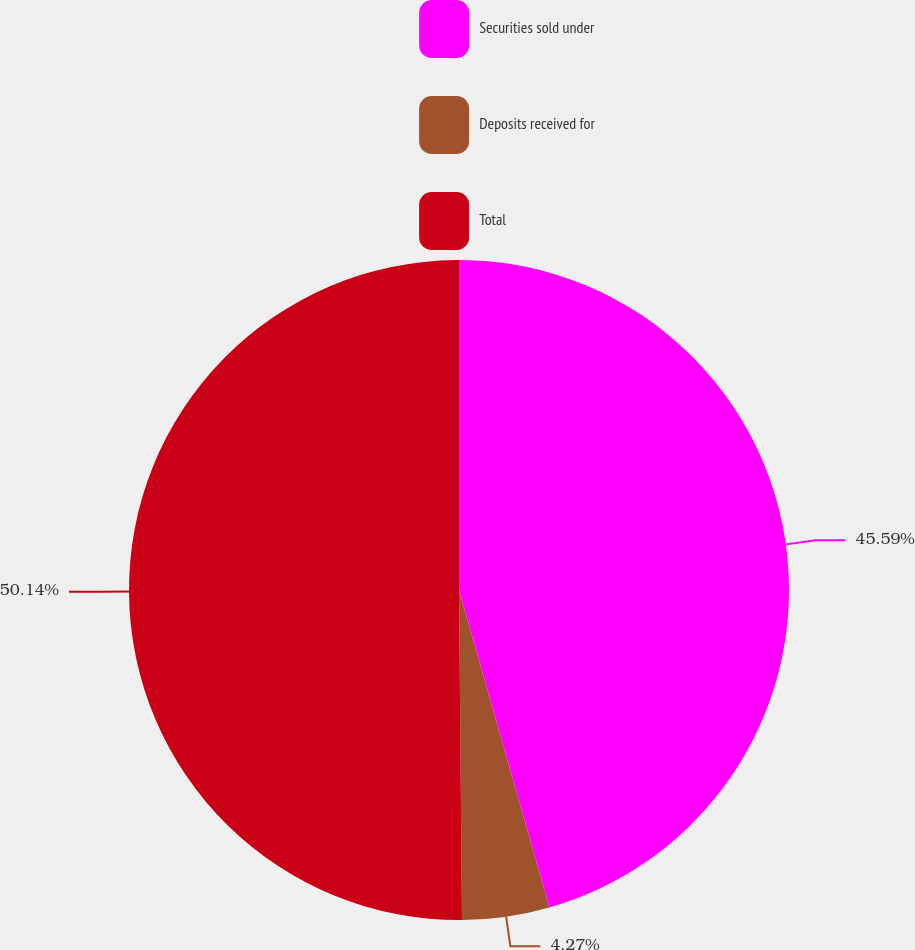<chart> <loc_0><loc_0><loc_500><loc_500><pie_chart><fcel>Securities sold under<fcel>Deposits received for<fcel>Total<nl><fcel>45.59%<fcel>4.27%<fcel>50.15%<nl></chart> 